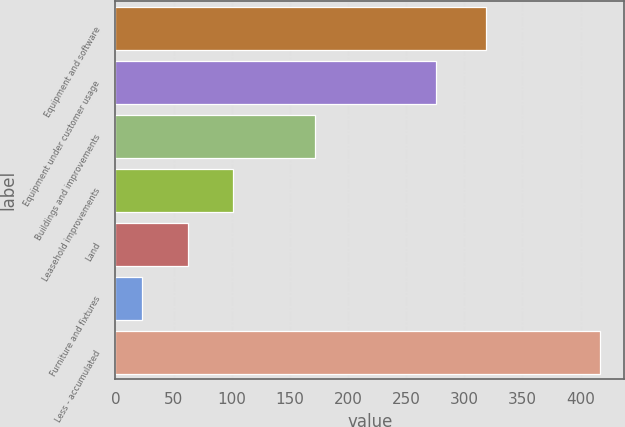<chart> <loc_0><loc_0><loc_500><loc_500><bar_chart><fcel>Equipment and software<fcel>Equipment under customer usage<fcel>Buildings and improvements<fcel>Leasehold improvements<fcel>Land<fcel>Furniture and fixtures<fcel>Less - accumulated<nl><fcel>318.5<fcel>275.7<fcel>171.5<fcel>101.38<fcel>61.99<fcel>22.6<fcel>416.5<nl></chart> 